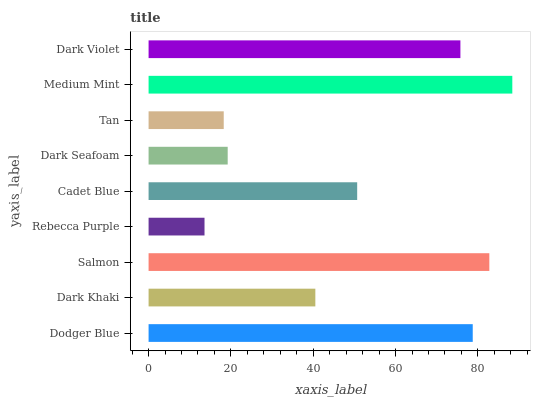Is Rebecca Purple the minimum?
Answer yes or no. Yes. Is Medium Mint the maximum?
Answer yes or no. Yes. Is Dark Khaki the minimum?
Answer yes or no. No. Is Dark Khaki the maximum?
Answer yes or no. No. Is Dodger Blue greater than Dark Khaki?
Answer yes or no. Yes. Is Dark Khaki less than Dodger Blue?
Answer yes or no. Yes. Is Dark Khaki greater than Dodger Blue?
Answer yes or no. No. Is Dodger Blue less than Dark Khaki?
Answer yes or no. No. Is Cadet Blue the high median?
Answer yes or no. Yes. Is Cadet Blue the low median?
Answer yes or no. Yes. Is Medium Mint the high median?
Answer yes or no. No. Is Medium Mint the low median?
Answer yes or no. No. 